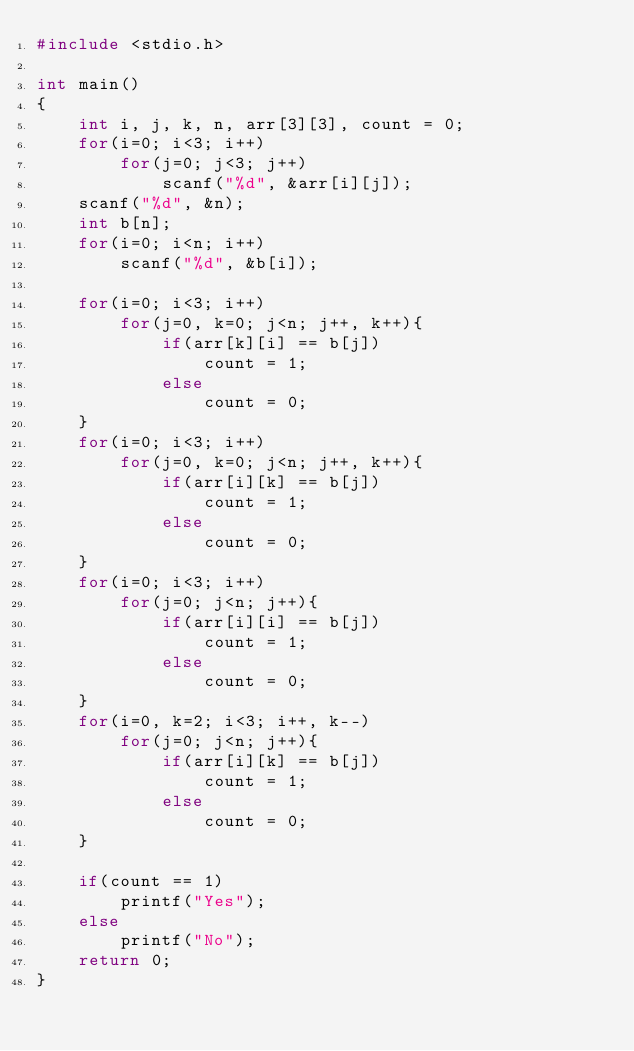Convert code to text. <code><loc_0><loc_0><loc_500><loc_500><_C++_>#include <stdio.h>

int main()
{
    int i, j, k, n, arr[3][3], count = 0;
    for(i=0; i<3; i++)
        for(j=0; j<3; j++)
            scanf("%d", &arr[i][j]);
    scanf("%d", &n);
    int b[n];
    for(i=0; i<n; i++)
        scanf("%d", &b[i]);

    for(i=0; i<3; i++)
        for(j=0, k=0; j<n; j++, k++){
            if(arr[k][i] == b[j])
                count = 1;
            else
                count = 0;
    }
    for(i=0; i<3; i++)
        for(j=0, k=0; j<n; j++, k++){
            if(arr[i][k] == b[j])
                count = 1;
            else
                count = 0;
    }
    for(i=0; i<3; i++)
        for(j=0; j<n; j++){
            if(arr[i][i] == b[j])
                count = 1;
            else
                count = 0;
    }
    for(i=0, k=2; i<3; i++, k--)
        for(j=0; j<n; j++){
            if(arr[i][k] == b[j])
                count = 1;
            else
                count = 0;
    }

    if(count == 1)
        printf("Yes");
    else
        printf("No");
    return 0;
}</code> 